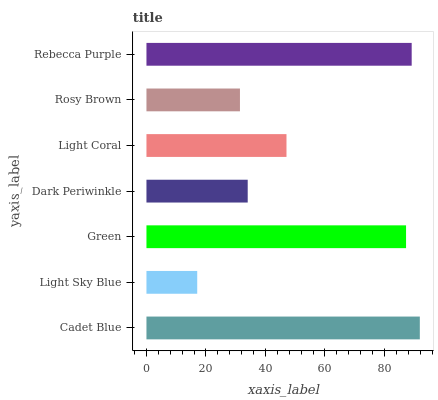Is Light Sky Blue the minimum?
Answer yes or no. Yes. Is Cadet Blue the maximum?
Answer yes or no. Yes. Is Green the minimum?
Answer yes or no. No. Is Green the maximum?
Answer yes or no. No. Is Green greater than Light Sky Blue?
Answer yes or no. Yes. Is Light Sky Blue less than Green?
Answer yes or no. Yes. Is Light Sky Blue greater than Green?
Answer yes or no. No. Is Green less than Light Sky Blue?
Answer yes or no. No. Is Light Coral the high median?
Answer yes or no. Yes. Is Light Coral the low median?
Answer yes or no. Yes. Is Light Sky Blue the high median?
Answer yes or no. No. Is Cadet Blue the low median?
Answer yes or no. No. 